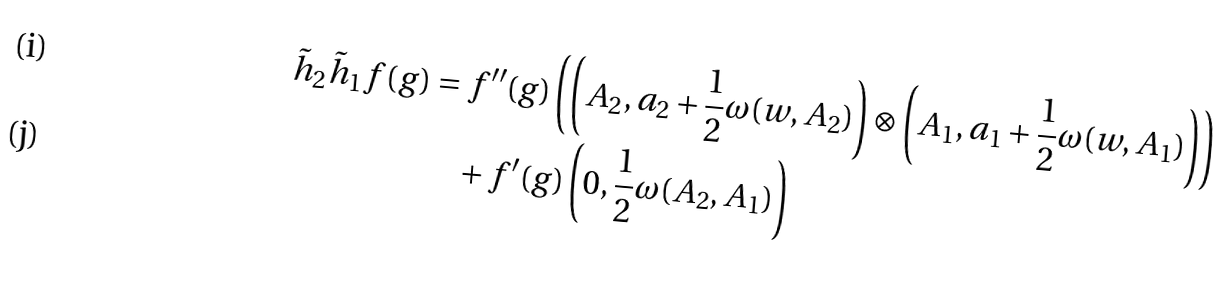<formula> <loc_0><loc_0><loc_500><loc_500>\tilde { h } _ { 2 } \tilde { h } _ { 1 } f ( g ) & = f ^ { \prime \prime } ( g ) \left ( \left ( A _ { 2 } , a _ { 2 } + \frac { 1 } { 2 } \omega ( w , A _ { 2 } ) \right ) \otimes \left ( A _ { 1 } , a _ { 1 } + \frac { 1 } { 2 } \omega ( w , A _ { 1 } ) \right ) \right ) \\ & \quad + f ^ { \prime } ( g ) \left ( 0 , \frac { 1 } { 2 } \omega ( A _ { 2 } , A _ { 1 } ) \right )</formula> 